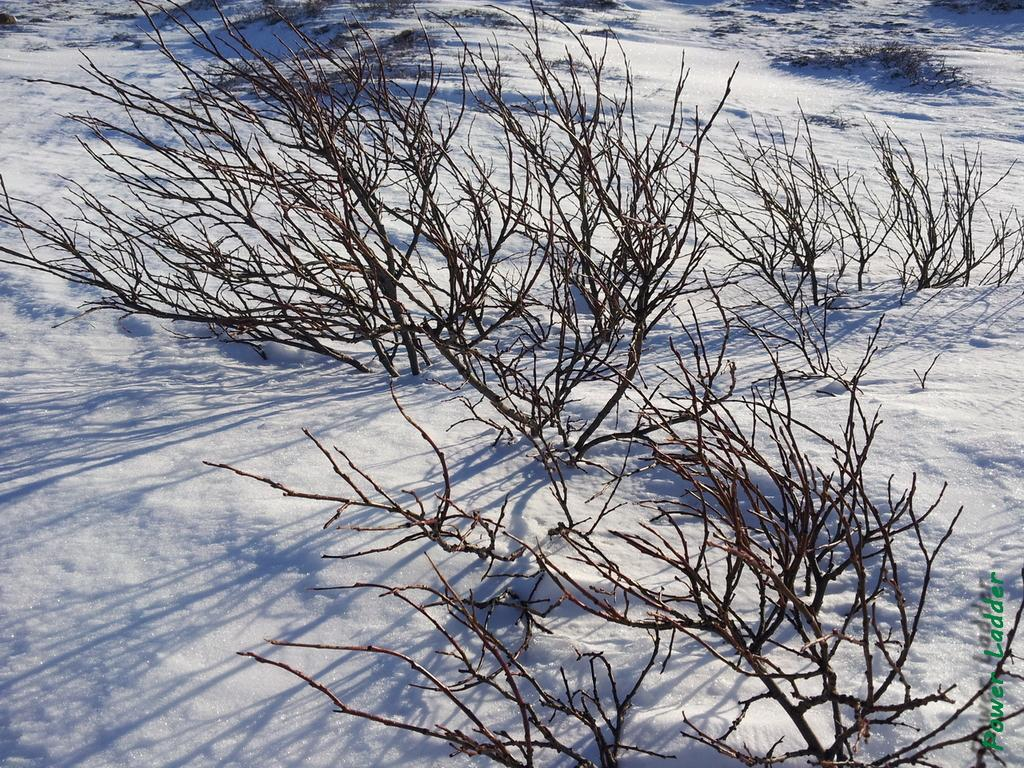What is the primary feature of the landscape in the image? The image contains snow. What type of trees can be seen in the image? There are bare trees in the image. What religious ceremony is taking place in the image? There is no religious ceremony present in the image; it only contains snow and bare trees. What is the zinc content of the snow in the image? There is no information provided about the chemical composition of the snow, so it is impossible to determine the zinc content. 